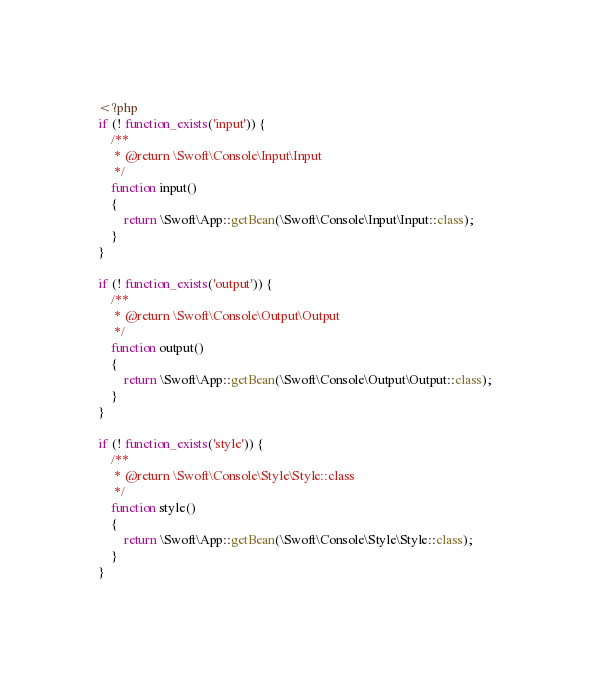Convert code to text. <code><loc_0><loc_0><loc_500><loc_500><_PHP_><?php
if (! function_exists('input')) {
    /**
     * @return \Swoft\Console\Input\Input
     */
    function input()
    {
        return \Swoft\App::getBean(\Swoft\Console\Input\Input::class);
    }
}

if (! function_exists('output')) {
    /**
     * @return \Swoft\Console\Output\Output
     */
    function output()
    {
        return \Swoft\App::getBean(\Swoft\Console\Output\Output::class);
    }
}

if (! function_exists('style')) {
    /**
     * @return \Swoft\Console\Style\Style::class
     */
    function style()
    {
        return \Swoft\App::getBean(\Swoft\Console\Style\Style::class);
    }
}
</code> 